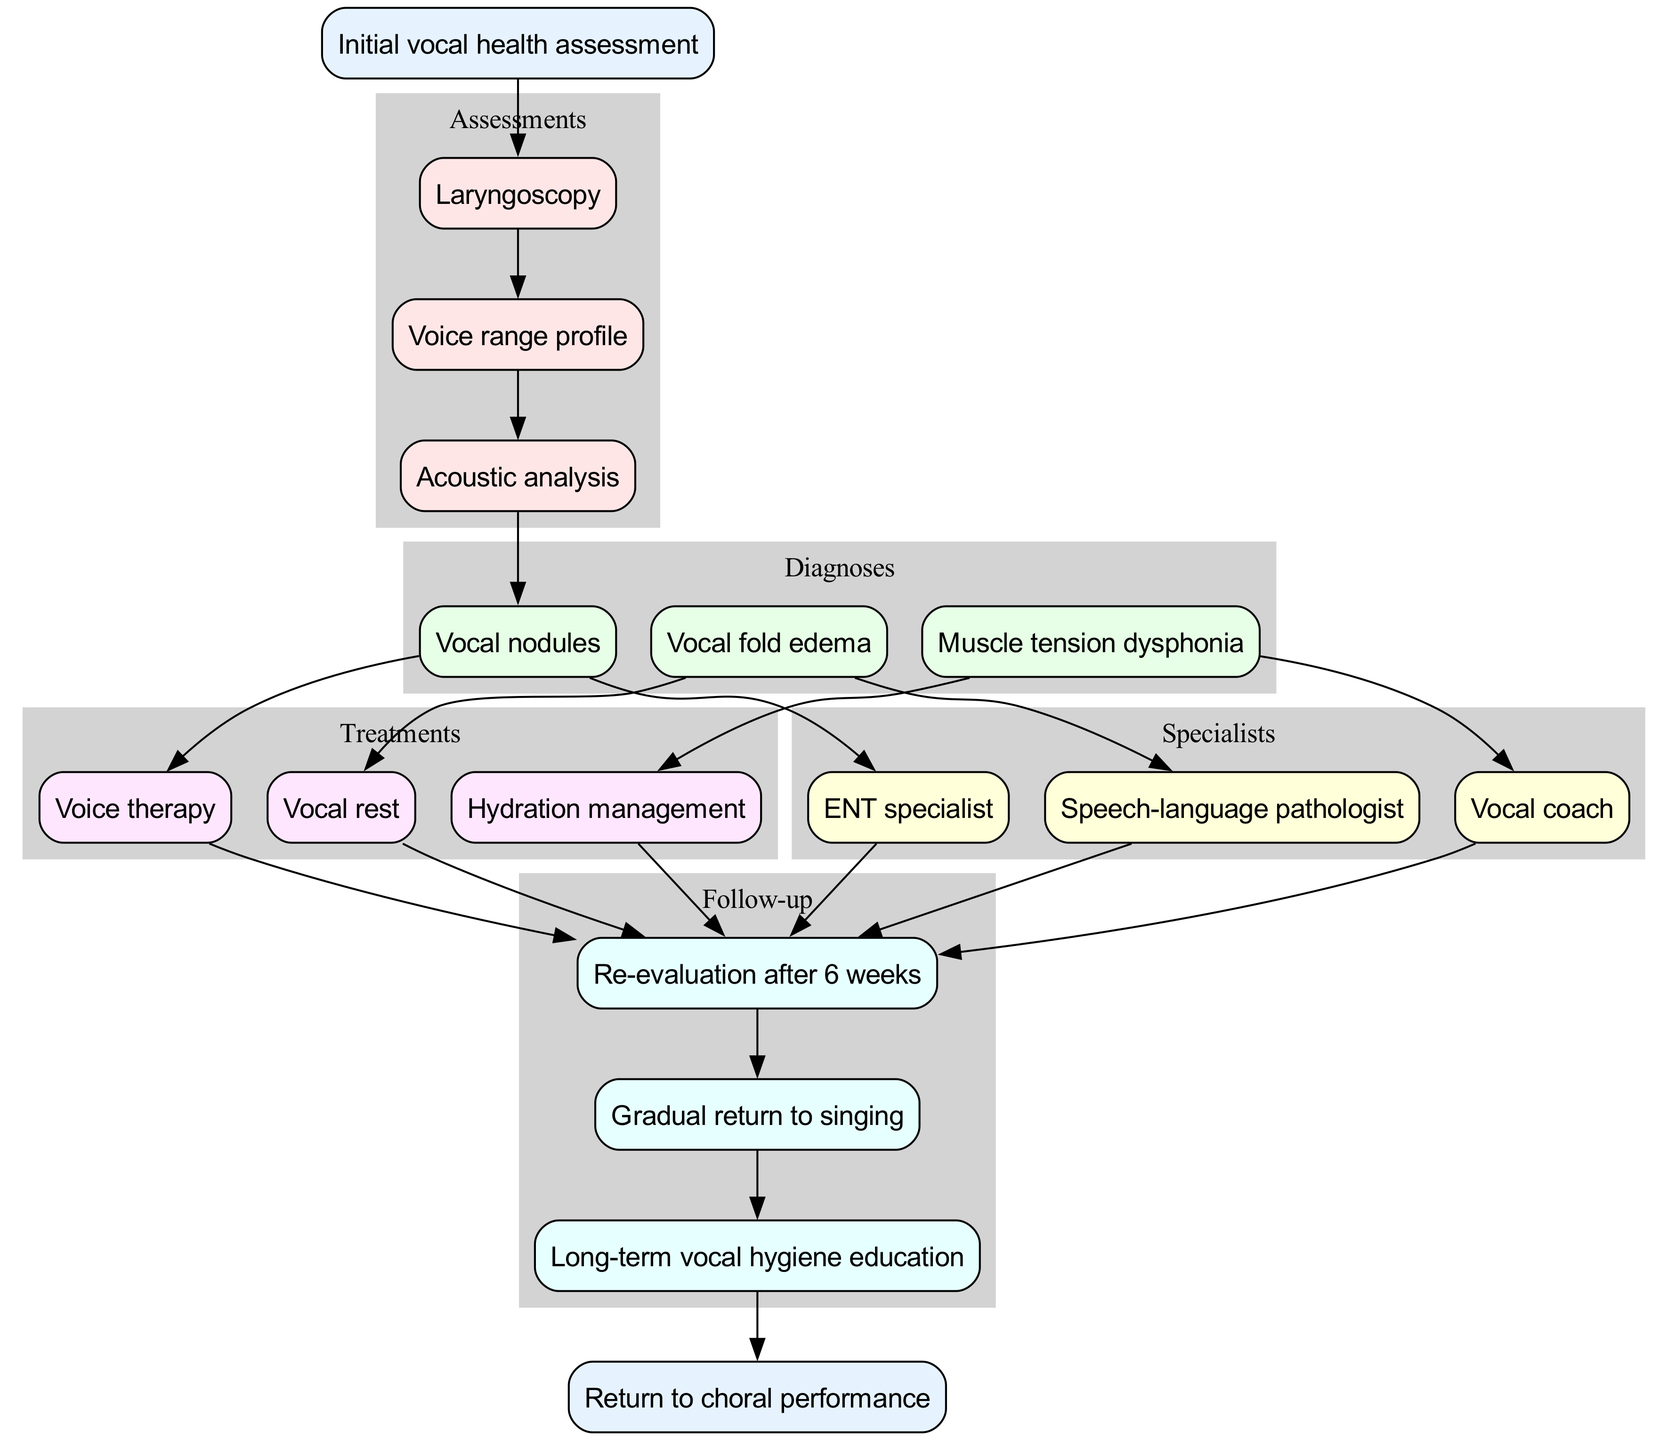What is the starting point of the clinical pathway? The diagram indicates "Initial vocal health assessment" as the starting point.
Answer: Initial vocal health assessment How many assessments are listed in the pathway? Counting the nodes under assessments, there are three listed: Laryngoscopy, Voice range profile, and Acoustic analysis.
Answer: 3 Which diagnosis is connected to the third assessment? The last assessment connects to the "Vocal nodules" diagnosis node as it's the first diagnosis linked after assessments.
Answer: Vocal nodules What treatment is associated with "Muscle tension dysphonia"? "Muscle tension dysphonia" is linked directly to "Voice therapy" as one of the treatments related to that diagnosis.
Answer: Voice therapy List the specialists involved in the clinical pathway. The specialists are indicated in the diagram as: ENT specialist, Speech-language pathologist, and Vocal coach.
Answer: ENT specialist, Speech-language pathologist, Vocal coach After how many weeks is the first follow-up scheduled? The diagram shows that re-evaluation is scheduled after 6 weeks following the treatments.
Answer: 6 weeks What is the final step in the clinical pathway? The end node indicates that the final outcome of the clinical pathway is "Return to choral performance."
Answer: Return to choral performance Which treatment is linked to every diagnosis listed in the pathway? Upon examining the treatments connected to each diagnosis, "Vocal rest" is consistently present, signifying its importance.
Answer: Vocal rest What flows directly after the follow-up process? The follow-up steps lead to the end node, indicating the conclusion of the clinical pathway is to return to choral performance.
Answer: Return to choral performance 